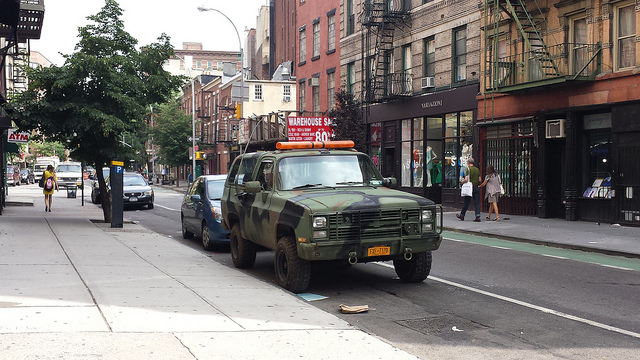What is the overall condition of the street, and what does it say about the area's maintenance? The street appears well-maintained, with visible lane markings and no significant debris. This suggests regular upkeep and a city infrastructure capable of maintaining its public spaces, indicating an area that is taken care of by local services. 